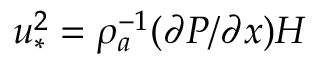Convert formula to latex. <formula><loc_0><loc_0><loc_500><loc_500>u _ { \ast } ^ { 2 } = \rho _ { a } ^ { - 1 } ( \partial P / \partial x ) H</formula> 